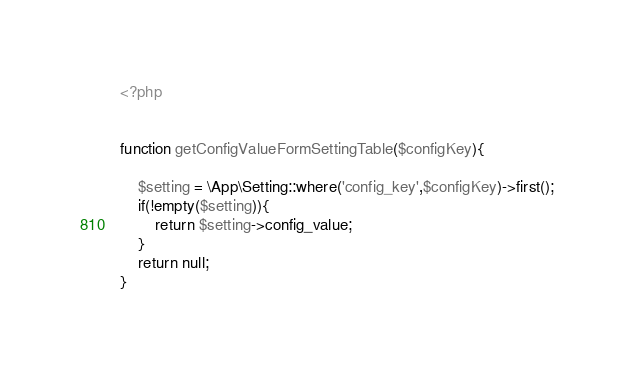Convert code to text. <code><loc_0><loc_0><loc_500><loc_500><_PHP_><?php


function getConfigValueFormSettingTable($configKey){

    $setting = \App\Setting::where('config_key',$configKey)->first();
    if(!empty($setting)){
        return $setting->config_value;
    }
    return null;
}
</code> 